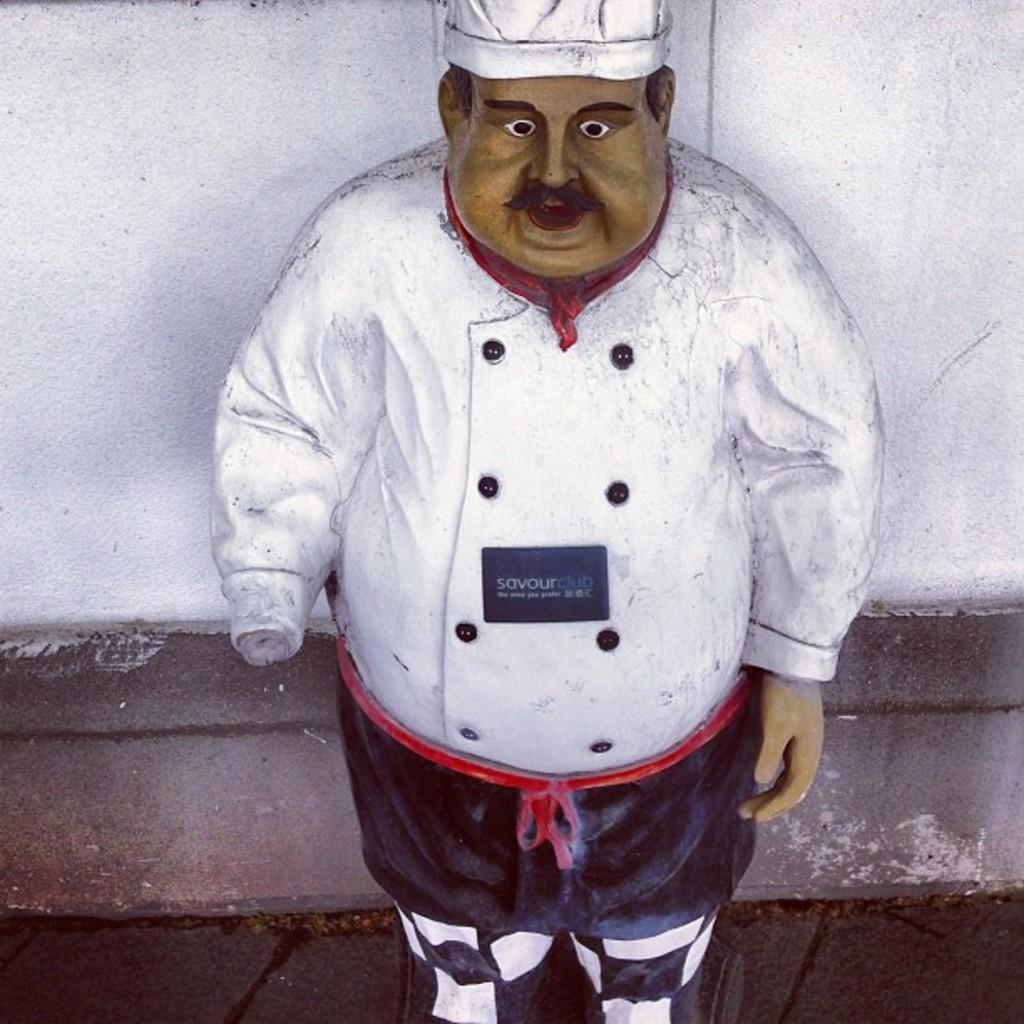What is the main subject of the image? There is a human statue in the image. Where is the human statue located? The human statue is on the floor. What is behind the human statue? There is a wall behind the human statue. What is the human statue wearing on their upper body? The human statue is wearing a white top. What type of headwear is the human statue wearing? The human statue is wearing a cap. Can you see any yaks near the seashore in the image? There is no seashore or yaks present in the image; it features a human statue on the floor with a wall behind it. 